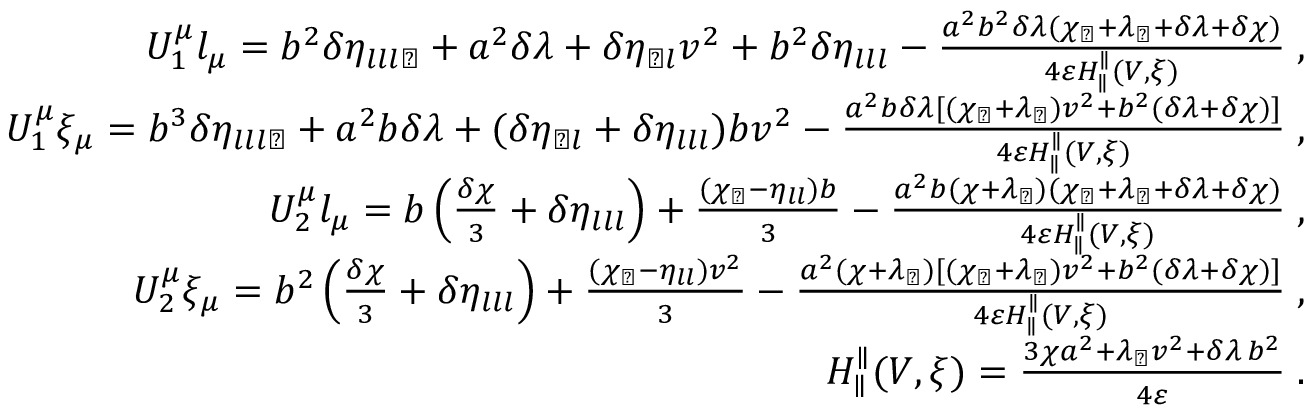Convert formula to latex. <formula><loc_0><loc_0><loc_500><loc_500>\begin{array} { r l r } & { U _ { 1 } ^ { \mu } l _ { \mu } = b ^ { 2 } \delta \eta _ { l l l \perp } + a ^ { 2 } \delta \lambda + \delta \eta _ { \perp l } v ^ { 2 } + b ^ { 2 } \delta \eta _ { l l l } - \frac { a ^ { 2 } b ^ { 2 } \delta \lambda ( \chi _ { \perp } + \lambda _ { \perp } + \delta \lambda + \delta \chi ) } { 4 \varepsilon H _ { \| } ^ { \| } ( V , \xi ) } \, , } \\ & { U _ { 1 } ^ { \mu } \xi _ { \mu } = b ^ { 3 } \delta \eta _ { l l l \perp } + a ^ { 2 } b \delta \lambda + ( \delta \eta _ { \perp l } + \delta \eta _ { l l l } ) b v ^ { 2 } - \frac { a ^ { 2 } b \delta \lambda [ ( \chi _ { \perp } + \lambda _ { \perp } ) v ^ { 2 } + b ^ { 2 } ( \delta \lambda + \delta \chi ) ] } { 4 \varepsilon H _ { \| } ^ { \| } ( V , \xi ) } \, , } \\ & { U _ { 2 } ^ { \mu } l _ { \mu } = b \left ( \frac { \delta \chi } { 3 } + \delta \eta _ { l l l } \right ) + \frac { ( \chi _ { \perp } - \eta _ { l l } ) b } { 3 } - \frac { a ^ { 2 } b ( \chi + \lambda _ { \perp } ) ( \chi _ { \perp } + \lambda _ { \perp } + \delta \lambda + \delta \chi ) } { 4 \varepsilon H _ { \| } ^ { \| } ( V , \xi ) } \, , } \\ & { U _ { 2 } ^ { \mu } \xi _ { \mu } = b ^ { 2 } \left ( \frac { \delta \chi } { 3 } + \delta \eta _ { l l l } \right ) + \frac { ( \chi _ { \perp } - \eta _ { l l } ) v ^ { 2 } } { 3 } - \frac { a ^ { 2 } ( \chi + \lambda _ { \perp } ) [ ( \chi _ { \perp } + \lambda _ { \perp } ) v ^ { 2 } + b ^ { 2 } ( \delta \lambda + \delta \chi ) ] } { 4 \varepsilon H _ { \| } ^ { \| } ( V , \xi ) } \, , } \\ & { H _ { \| } ^ { \| } ( V , \xi ) = \frac { 3 \chi a ^ { 2 } + \lambda _ { \perp } v ^ { 2 } + \delta \lambda \, b ^ { 2 } } { 4 \varepsilon } \, . } \end{array}</formula> 